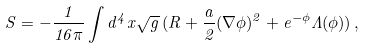<formula> <loc_0><loc_0><loc_500><loc_500>S = - \frac { 1 } { 1 6 \pi } \int d ^ { 4 } x \sqrt { g } \, ( R + \frac { a } { 2 } ( \nabla \phi ) ^ { 2 } + e ^ { - \phi } \Lambda ( \phi ) ) \, ,</formula> 